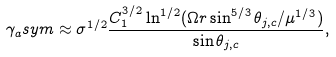<formula> <loc_0><loc_0><loc_500><loc_500>\gamma _ { a } s y m \approx \sigma ^ { 1 / 2 } \frac { C _ { 1 } ^ { 3 / 2 } \ln ^ { 1 / 2 } ( \Omega r \sin ^ { 5 / 3 } \theta _ { j , c } / \mu ^ { 1 / 3 } ) } { \sin \theta _ { j , c } } ,</formula> 